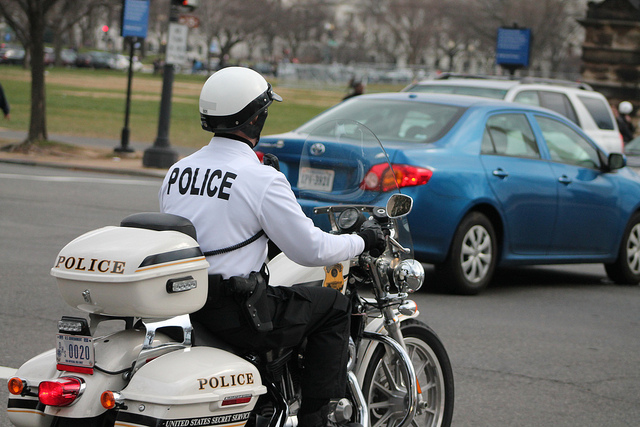Please identify all text content in this image. POLICE POLICE POLICE 0020 UNITED STATES 